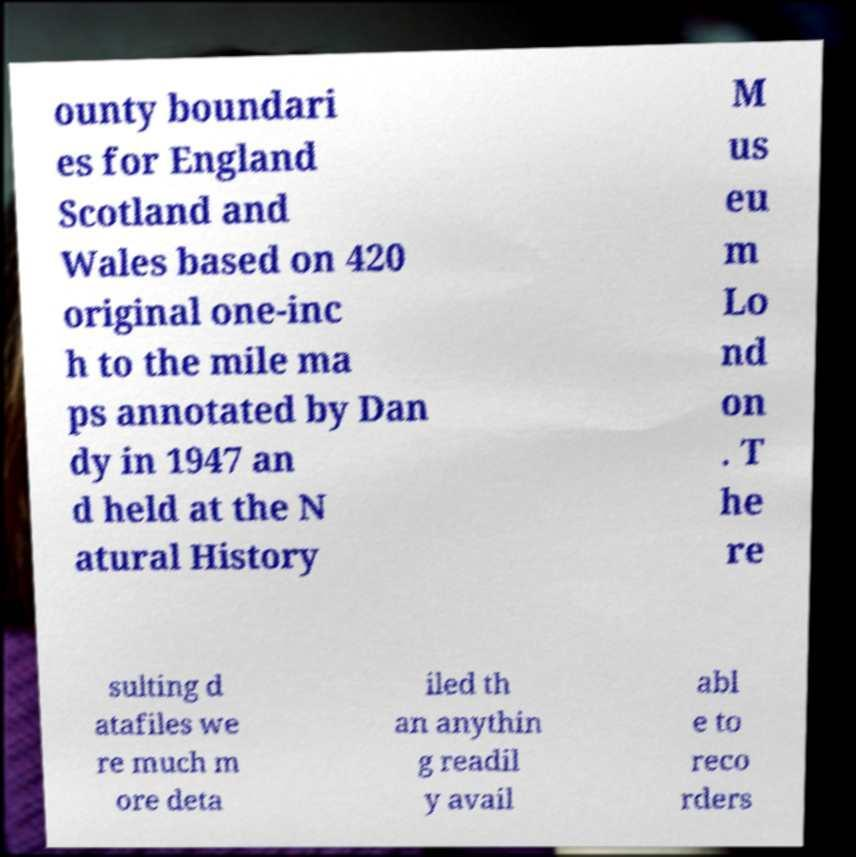Can you read and provide the text displayed in the image?This photo seems to have some interesting text. Can you extract and type it out for me? ounty boundari es for England Scotland and Wales based on 420 original one-inc h to the mile ma ps annotated by Dan dy in 1947 an d held at the N atural History M us eu m Lo nd on . T he re sulting d atafiles we re much m ore deta iled th an anythin g readil y avail abl e to reco rders 